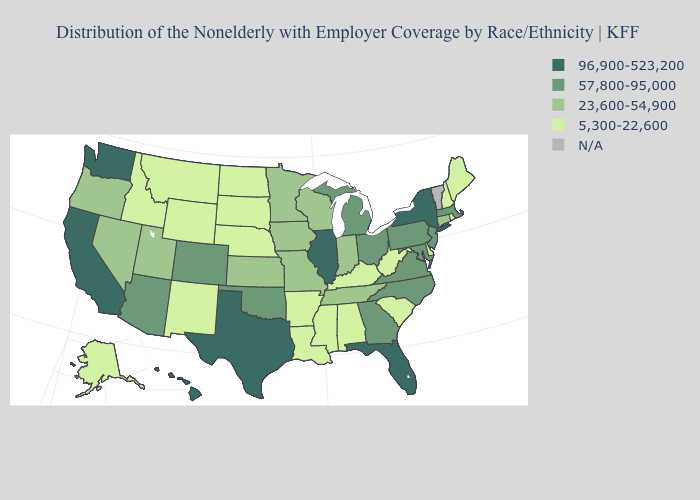What is the highest value in the USA?
Be succinct. 96,900-523,200. Name the states that have a value in the range 96,900-523,200?
Quick response, please. California, Florida, Hawaii, Illinois, New York, Texas, Washington. Name the states that have a value in the range 57,800-95,000?
Concise answer only. Arizona, Colorado, Georgia, Maryland, Massachusetts, Michigan, New Jersey, North Carolina, Ohio, Oklahoma, Pennsylvania, Virginia. Among the states that border Delaware , which have the lowest value?
Concise answer only. Maryland, New Jersey, Pennsylvania. What is the value of Mississippi?
Give a very brief answer. 5,300-22,600. Name the states that have a value in the range 96,900-523,200?
Keep it brief. California, Florida, Hawaii, Illinois, New York, Texas, Washington. How many symbols are there in the legend?
Answer briefly. 5. What is the lowest value in the USA?
Answer briefly. 5,300-22,600. What is the value of Ohio?
Be succinct. 57,800-95,000. What is the value of Ohio?
Keep it brief. 57,800-95,000. Name the states that have a value in the range 5,300-22,600?
Keep it brief. Alabama, Alaska, Arkansas, Delaware, Idaho, Kentucky, Louisiana, Maine, Mississippi, Montana, Nebraska, New Hampshire, New Mexico, North Dakota, Rhode Island, South Carolina, South Dakota, West Virginia, Wyoming. Which states have the lowest value in the Northeast?
Keep it brief. Maine, New Hampshire, Rhode Island. Among the states that border Arkansas , does Mississippi have the lowest value?
Short answer required. Yes. What is the value of Missouri?
Keep it brief. 23,600-54,900. 